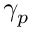Convert formula to latex. <formula><loc_0><loc_0><loc_500><loc_500>\gamma _ { p }</formula> 